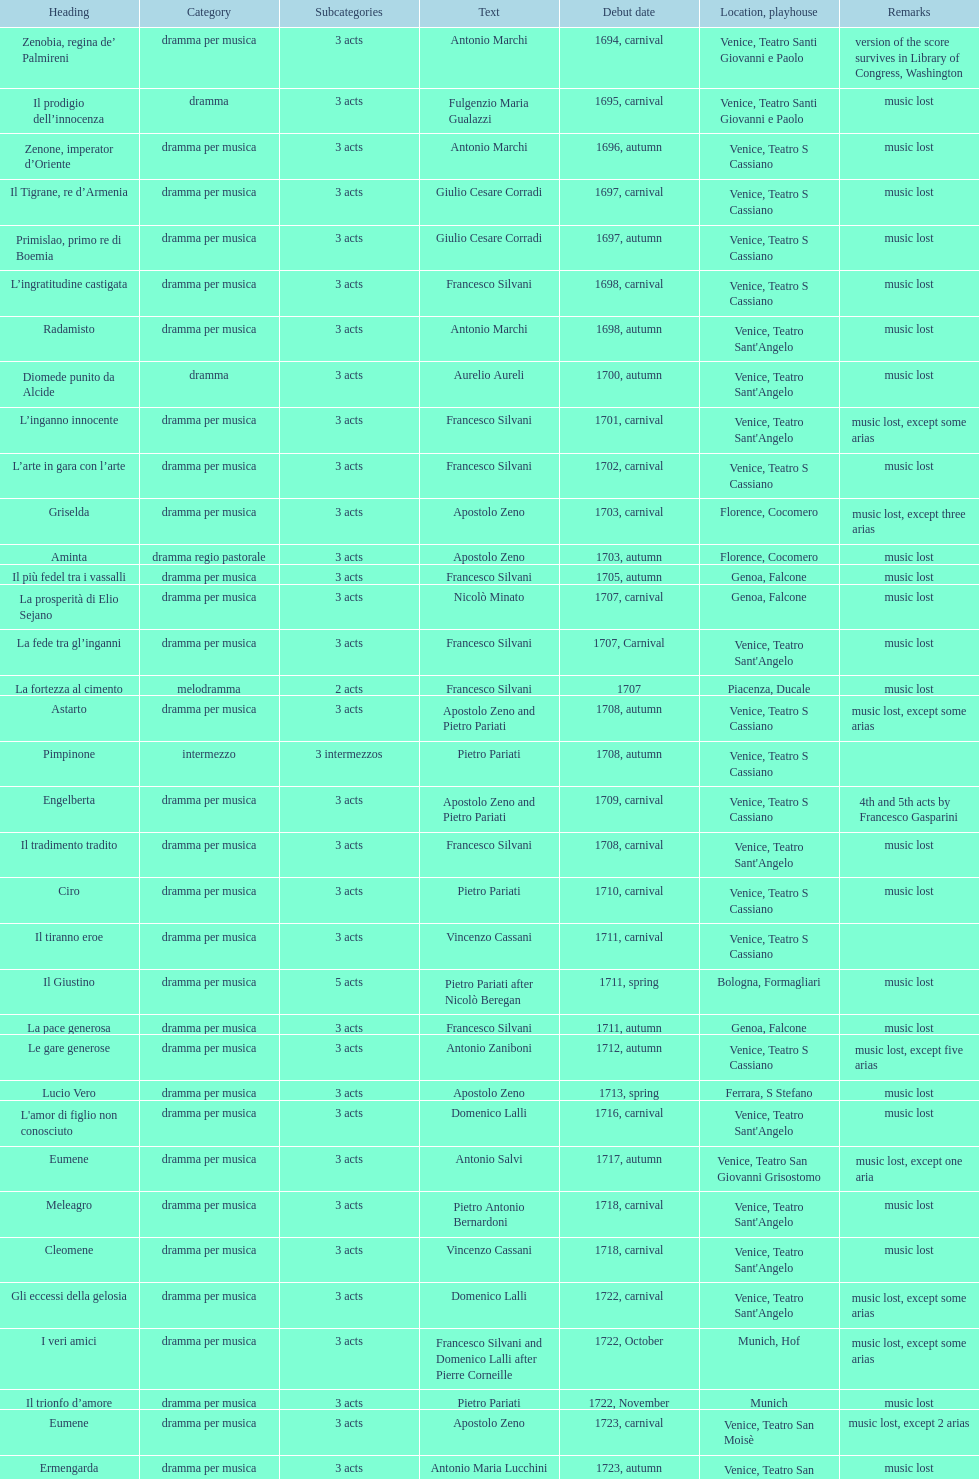Which opera has the most acts, la fortezza al cimento or astarto? Astarto. 